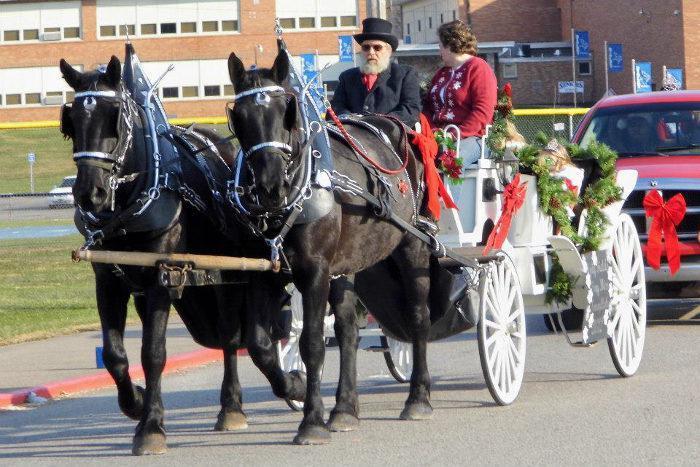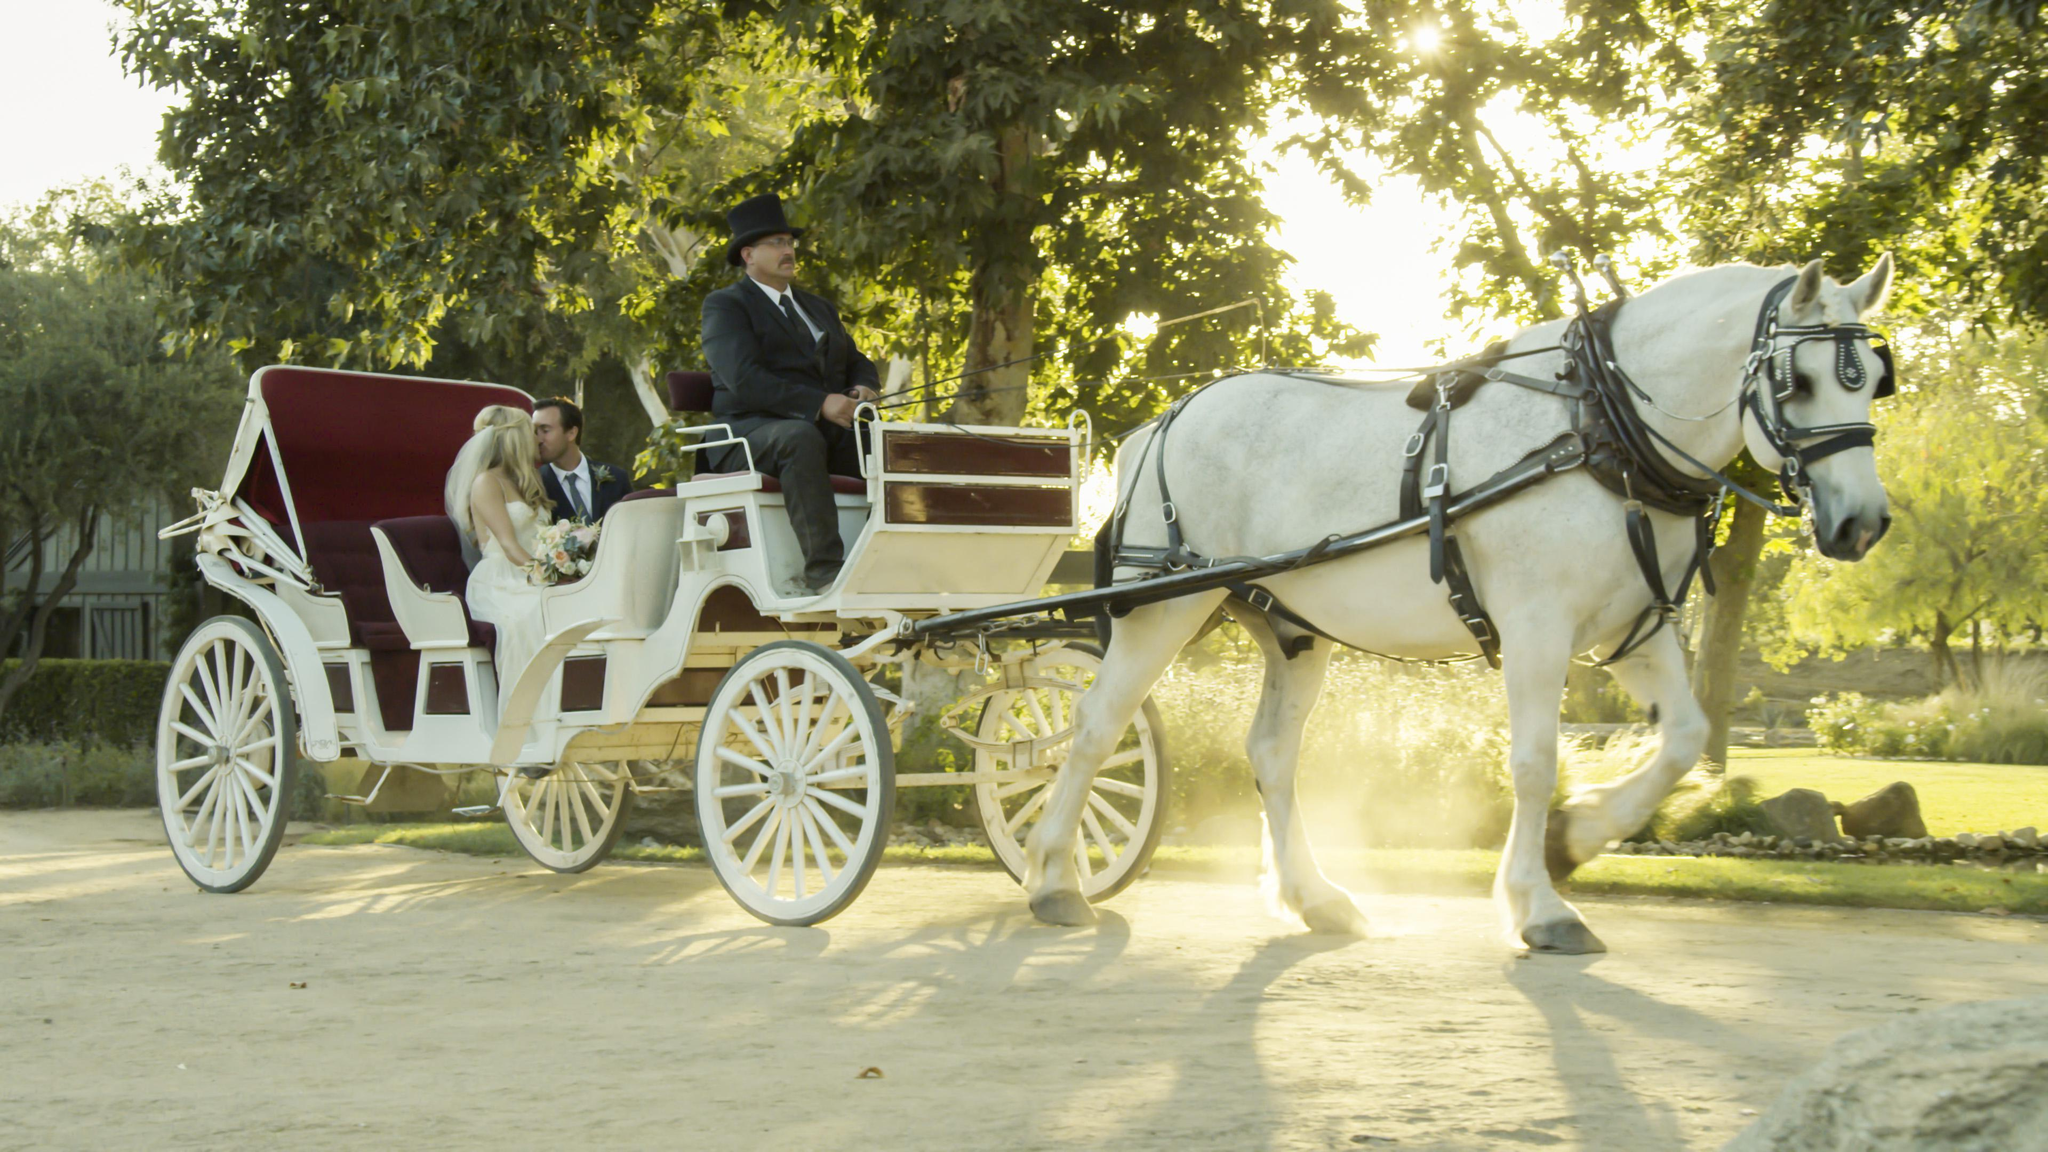The first image is the image on the left, the second image is the image on the right. Assess this claim about the two images: "There are more than five white horses in one of the images.". Correct or not? Answer yes or no. No. The first image is the image on the left, the second image is the image on the right. Given the left and right images, does the statement "A man is riding a horse pulled sleigh through the snow in the right image." hold true? Answer yes or no. No. 